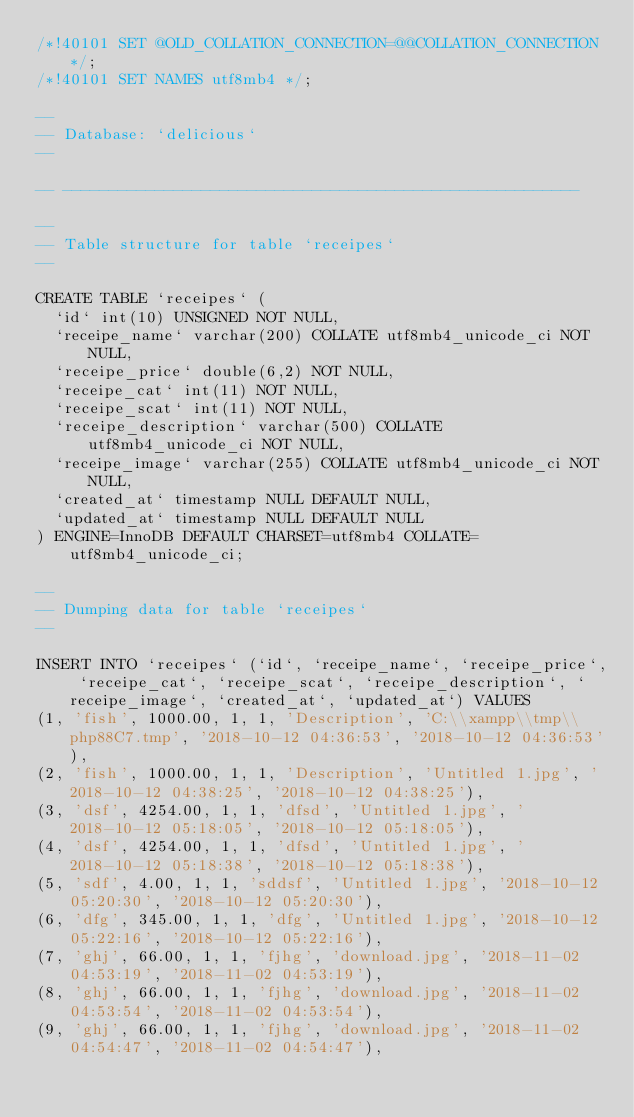Convert code to text. <code><loc_0><loc_0><loc_500><loc_500><_SQL_>/*!40101 SET @OLD_COLLATION_CONNECTION=@@COLLATION_CONNECTION */;
/*!40101 SET NAMES utf8mb4 */;

--
-- Database: `delicious`
--

-- --------------------------------------------------------

--
-- Table structure for table `receipes`
--

CREATE TABLE `receipes` (
  `id` int(10) UNSIGNED NOT NULL,
  `receipe_name` varchar(200) COLLATE utf8mb4_unicode_ci NOT NULL,
  `receipe_price` double(6,2) NOT NULL,
  `receipe_cat` int(11) NOT NULL,
  `receipe_scat` int(11) NOT NULL,
  `receipe_description` varchar(500) COLLATE utf8mb4_unicode_ci NOT NULL,
  `receipe_image` varchar(255) COLLATE utf8mb4_unicode_ci NOT NULL,
  `created_at` timestamp NULL DEFAULT NULL,
  `updated_at` timestamp NULL DEFAULT NULL
) ENGINE=InnoDB DEFAULT CHARSET=utf8mb4 COLLATE=utf8mb4_unicode_ci;

--
-- Dumping data for table `receipes`
--

INSERT INTO `receipes` (`id`, `receipe_name`, `receipe_price`, `receipe_cat`, `receipe_scat`, `receipe_description`, `receipe_image`, `created_at`, `updated_at`) VALUES
(1, 'fish', 1000.00, 1, 1, 'Description', 'C:\\xampp\\tmp\\php88C7.tmp', '2018-10-12 04:36:53', '2018-10-12 04:36:53'),
(2, 'fish', 1000.00, 1, 1, 'Description', 'Untitled 1.jpg', '2018-10-12 04:38:25', '2018-10-12 04:38:25'),
(3, 'dsf', 4254.00, 1, 1, 'dfsd', 'Untitled 1.jpg', '2018-10-12 05:18:05', '2018-10-12 05:18:05'),
(4, 'dsf', 4254.00, 1, 1, 'dfsd', 'Untitled 1.jpg', '2018-10-12 05:18:38', '2018-10-12 05:18:38'),
(5, 'sdf', 4.00, 1, 1, 'sddsf', 'Untitled 1.jpg', '2018-10-12 05:20:30', '2018-10-12 05:20:30'),
(6, 'dfg', 345.00, 1, 1, 'dfg', 'Untitled 1.jpg', '2018-10-12 05:22:16', '2018-10-12 05:22:16'),
(7, 'ghj', 66.00, 1, 1, 'fjhg', 'download.jpg', '2018-11-02 04:53:19', '2018-11-02 04:53:19'),
(8, 'ghj', 66.00, 1, 1, 'fjhg', 'download.jpg', '2018-11-02 04:53:54', '2018-11-02 04:53:54'),
(9, 'ghj', 66.00, 1, 1, 'fjhg', 'download.jpg', '2018-11-02 04:54:47', '2018-11-02 04:54:47'),</code> 